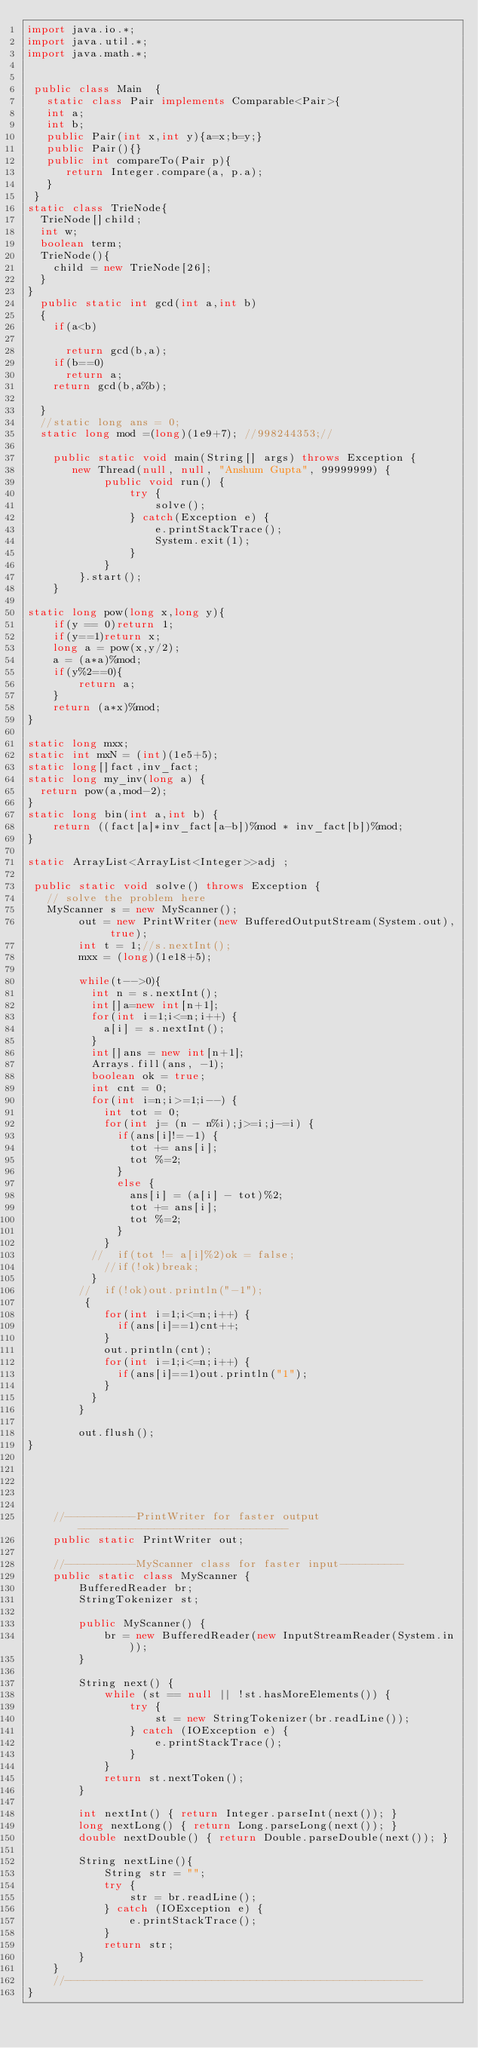Convert code to text. <code><loc_0><loc_0><loc_500><loc_500><_Java_>import java.io.*;
import java.util.*;
import java.math.*;

 
 public class Main	{
   static class Pair implements Comparable<Pair>{
   int a;
   int b;
   public Pair(int x,int y){a=x;b=y;}
   public Pair(){}
   public int compareTo(Pair p){
      return Integer.compare(a, p.a);
   }
 }
static class TrieNode{
  TrieNode[]child;
  int w;
  boolean term;
  TrieNode(){
    child = new TrieNode[26];  
  }
}
  public static int gcd(int a,int b)
  {
    if(a<b)

      return gcd(b,a);
    if(b==0)
      return a;
    return gcd(b,a%b);
    
  }
  //static long ans = 0;
  static long mod =(long)(1e9+7); //998244353;//
   
    public static void main(String[] args) throws Exception {
       new Thread(null, null, "Anshum Gupta", 99999999) {
            public void run() {
                try {
                    solve();
                } catch(Exception e) {
                    e.printStackTrace();
                    System.exit(1);
                }
            }
        }.start();
    }

static long pow(long x,long y){
    if(y == 0)return 1;
    if(y==1)return x;
    long a = pow(x,y/2);
    a = (a*a)%mod;
    if(y%2==0){
        return a;
    }
    return (a*x)%mod;
}

static long mxx;
static int mxN = (int)(1e5+5);
static long[]fact,inv_fact;
static long my_inv(long a) {
	return pow(a,mod-2);
}
static long bin(int a,int b) {
    return ((fact[a]*inv_fact[a-b])%mod * inv_fact[b])%mod;
}

static ArrayList<ArrayList<Integer>>adj ;

 public static void solve() throws Exception {
   // solve the problem here
   MyScanner s = new MyScanner();
        out = new PrintWriter(new BufferedOutputStream(System.out), true);
        int t = 1;//s.nextInt();
        mxx = (long)(1e18+5);
 
        while(t-->0){
        	int n = s.nextInt();
        	int[]a=new int[n+1];
        	for(int i=1;i<=n;i++) {
        		a[i] = s.nextInt();
        	}
        	int[]ans = new int[n+1];
        	Arrays.fill(ans, -1);
        	boolean ok = true;
        	int cnt = 0;
        	for(int i=n;i>=1;i--) {
        		int tot = 0;
        		for(int j= (n - n%i);j>=i;j-=i) {
        			if(ans[i]!=-1) {
        				tot += ans[i];
        				tot %=2;
        			}
        			else {
        				ans[i] = (a[i] - tot)%2;
        				tot += ans[i];
        				tot %=2;
        			}	
        		}
        	//	if(tot != a[i]%2)ok = false;
        		//if(!ok)break;
        	}
        //	if(!ok)out.println("-1");
         {
        		for(int i=1;i<=n;i++) {
        			if(ans[i]==1)cnt++;
        		}
        		out.println(cnt);
        		for(int i=1;i<=n;i++) {
        			if(ans[i]==1)out.println("1");
        		}
        	}
        }
           
        out.flush();
}
 
     
 
 
 
    //-----------PrintWriter for faster output---------------------------------
    public static PrintWriter out;
 
    //-----------MyScanner class for faster input----------
    public static class MyScanner {
        BufferedReader br;
        StringTokenizer st;
 
        public MyScanner() {
            br = new BufferedReader(new InputStreamReader(System.in));
        }
 
        String next() {
            while (st == null || !st.hasMoreElements()) {
                try {
                    st = new StringTokenizer(br.readLine());
                } catch (IOException e) {
                    e.printStackTrace();
                }
            }
            return st.nextToken();
        }
 
        int nextInt() { return Integer.parseInt(next()); }
        long nextLong() { return Long.parseLong(next()); }
        double nextDouble() { return Double.parseDouble(next()); }
         
        String nextLine(){
            String str = "";
            try {
                str = br.readLine();
            } catch (IOException e) {
                e.printStackTrace();
            }
            return str;
        }
    }
    //--------------------------------------------------------
}
</code> 